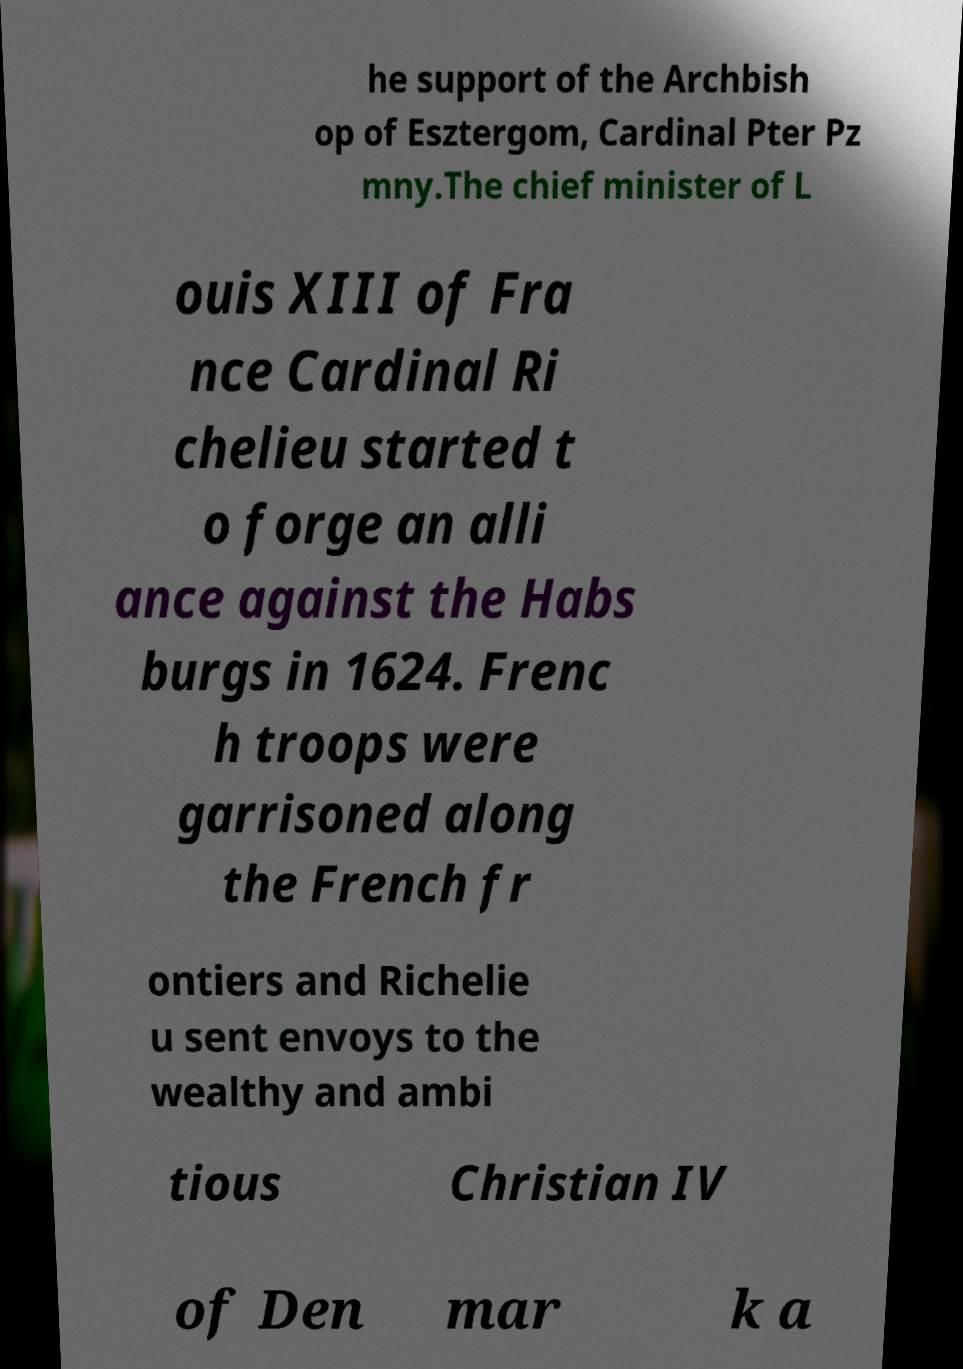Please identify and transcribe the text found in this image. he support of the Archbish op of Esztergom, Cardinal Pter Pz mny.The chief minister of L ouis XIII of Fra nce Cardinal Ri chelieu started t o forge an alli ance against the Habs burgs in 1624. Frenc h troops were garrisoned along the French fr ontiers and Richelie u sent envoys to the wealthy and ambi tious Christian IV of Den mar k a 